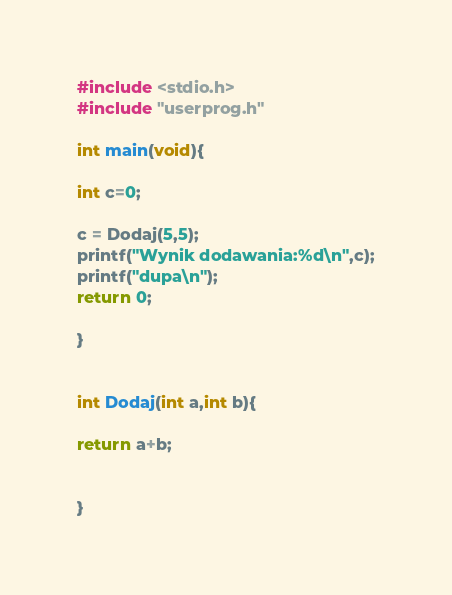Convert code to text. <code><loc_0><loc_0><loc_500><loc_500><_C_>#include <stdio.h>
#include "userprog.h"

int main(void){

int c=0;

c = Dodaj(5,5);
printf("Wynik dodawania:%d\n",c);
printf("dupa\n");
return 0;

}


int Dodaj(int a,int b){

return a+b;


}</code> 